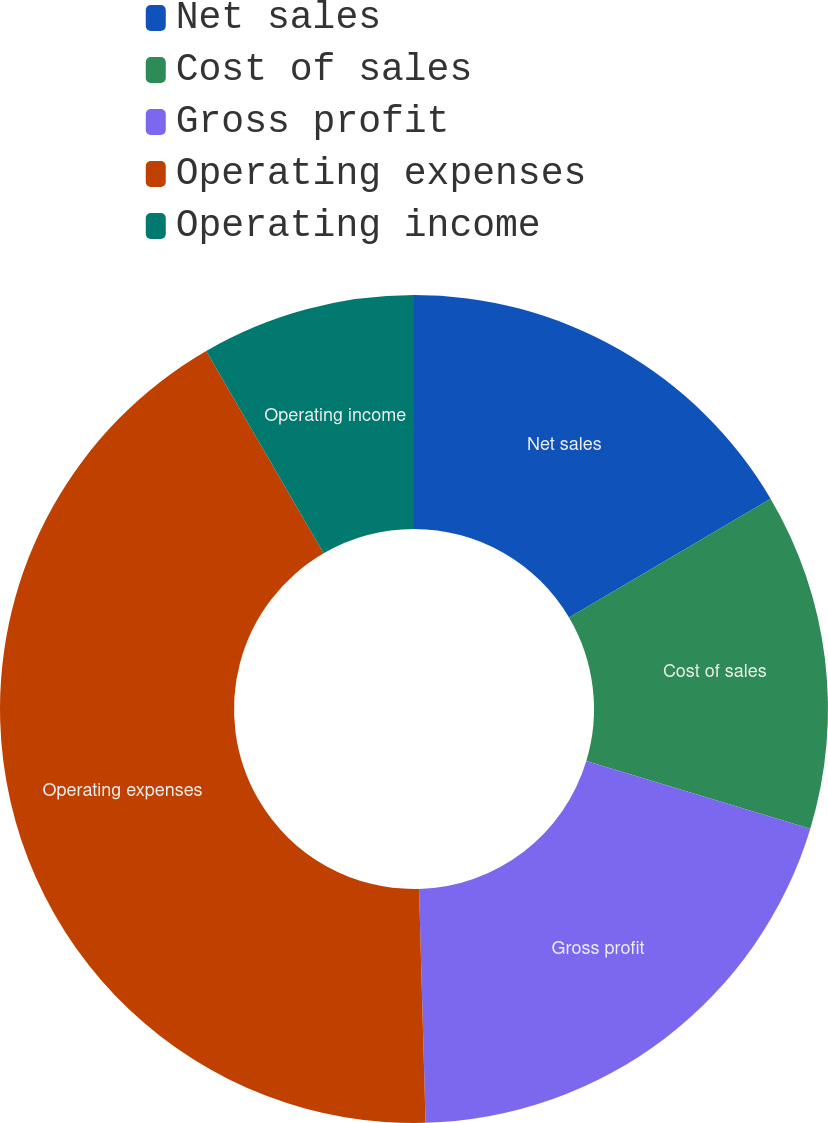Convert chart to OTSL. <chart><loc_0><loc_0><loc_500><loc_500><pie_chart><fcel>Net sales<fcel>Cost of sales<fcel>Gross profit<fcel>Operating expenses<fcel>Operating income<nl><fcel>16.52%<fcel>13.15%<fcel>19.89%<fcel>42.08%<fcel>8.37%<nl></chart> 